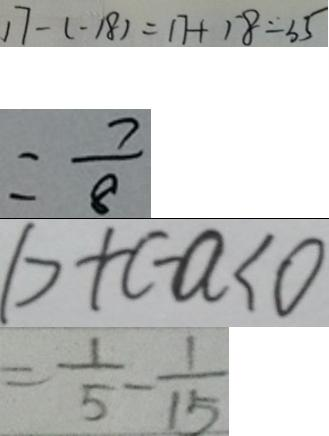<formula> <loc_0><loc_0><loc_500><loc_500>1 7 - ( - 1 8 ) = 1 7 + 1 8 = 3 5 
 = \frac { 7 } { 8 } 
 b + c - a < 0 
 = \frac { 1 } { 5 } - \frac { 1 } { 1 5 }</formula> 